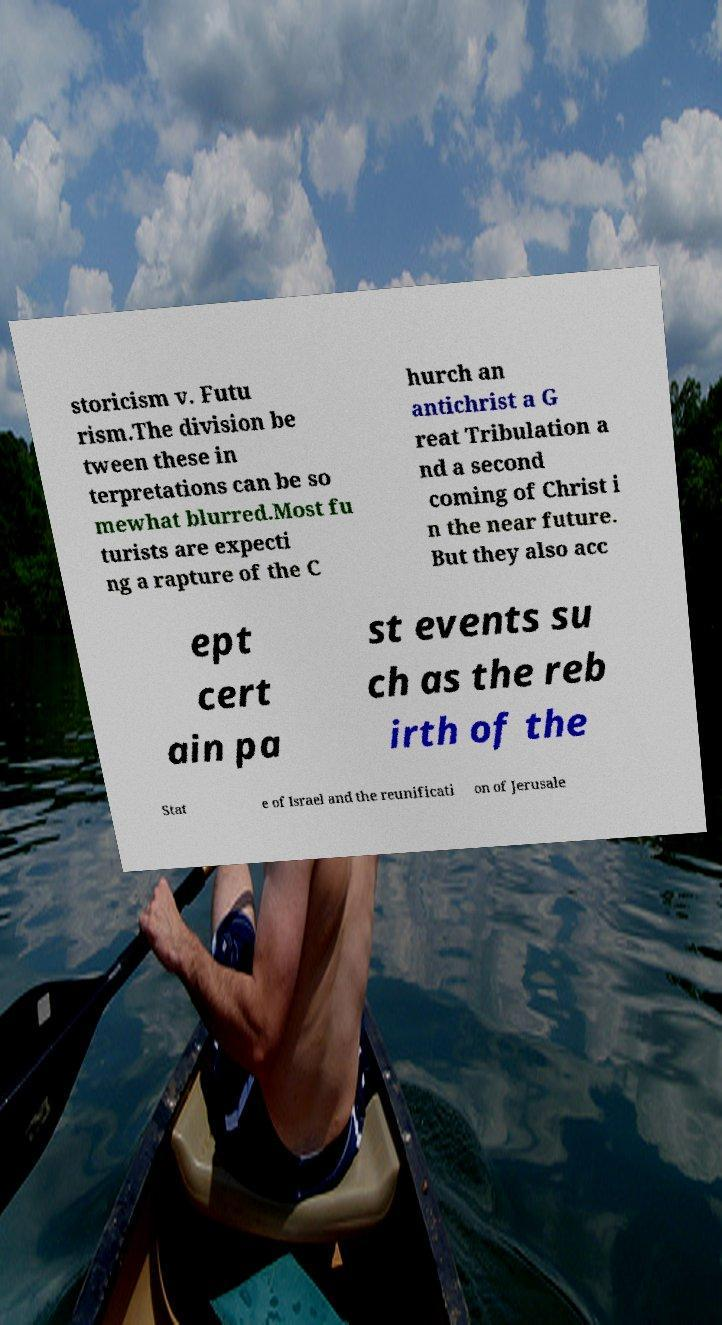For documentation purposes, I need the text within this image transcribed. Could you provide that? storicism v. Futu rism.The division be tween these in terpretations can be so mewhat blurred.Most fu turists are expecti ng a rapture of the C hurch an antichrist a G reat Tribulation a nd a second coming of Christ i n the near future. But they also acc ept cert ain pa st events su ch as the reb irth of the Stat e of Israel and the reunificati on of Jerusale 